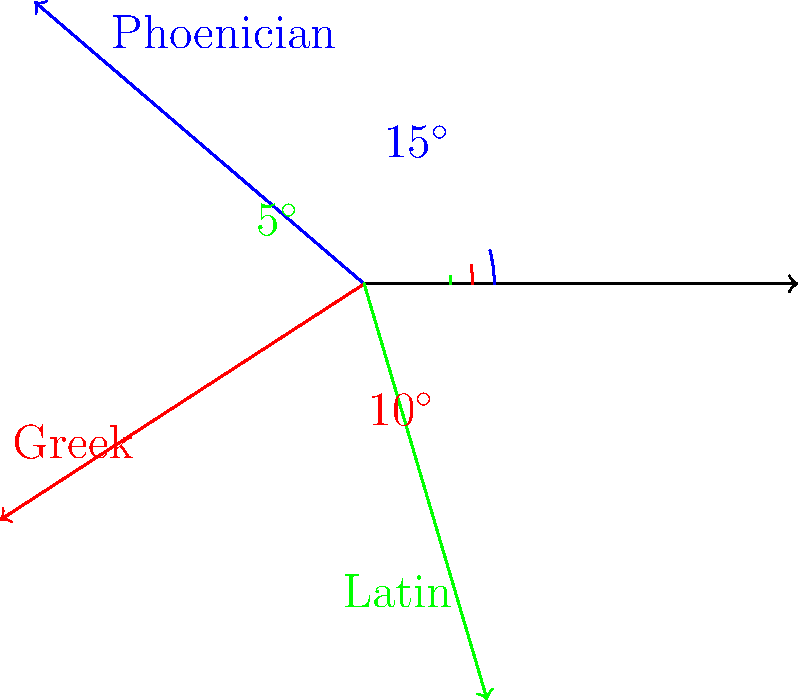Based on the diagram showing letter slants in ancient alphabets, what is the difference in degrees between the Phoenician and Latin letter slants? To find the difference in degrees between the Phoenician and Latin letter slants, we need to:

1. Identify the angle for the Phoenician alphabet slant:
   The Phoenician slant is marked as $15^\circ$.

2. Identify the angle for the Latin alphabet slant:
   The Latin slant is marked as $5^\circ$.

3. Calculate the difference between these two angles:
   $$15^\circ - 5^\circ = 10^\circ$$

Therefore, the difference in degrees between the Phoenician and Latin letter slants is $10^\circ$.
Answer: $10^\circ$ 